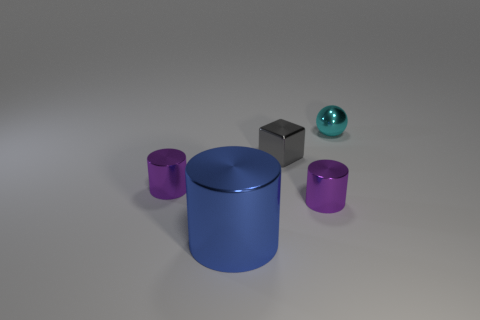Add 3 big red rubber objects. How many objects exist? 8 Subtract all blocks. How many objects are left? 4 Add 2 small cyan spheres. How many small cyan spheres exist? 3 Subtract 1 blue cylinders. How many objects are left? 4 Subtract all small metal spheres. Subtract all small spheres. How many objects are left? 3 Add 5 tiny things. How many tiny things are left? 9 